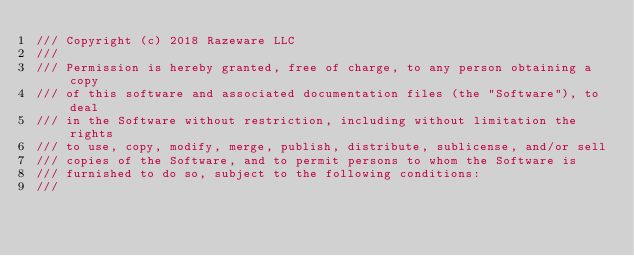<code> <loc_0><loc_0><loc_500><loc_500><_Swift_>/// Copyright (c) 2018 Razeware LLC
///
/// Permission is hereby granted, free of charge, to any person obtaining a copy
/// of this software and associated documentation files (the "Software"), to deal
/// in the Software without restriction, including without limitation the rights
/// to use, copy, modify, merge, publish, distribute, sublicense, and/or sell
/// copies of the Software, and to permit persons to whom the Software is
/// furnished to do so, subject to the following conditions:
///</code> 